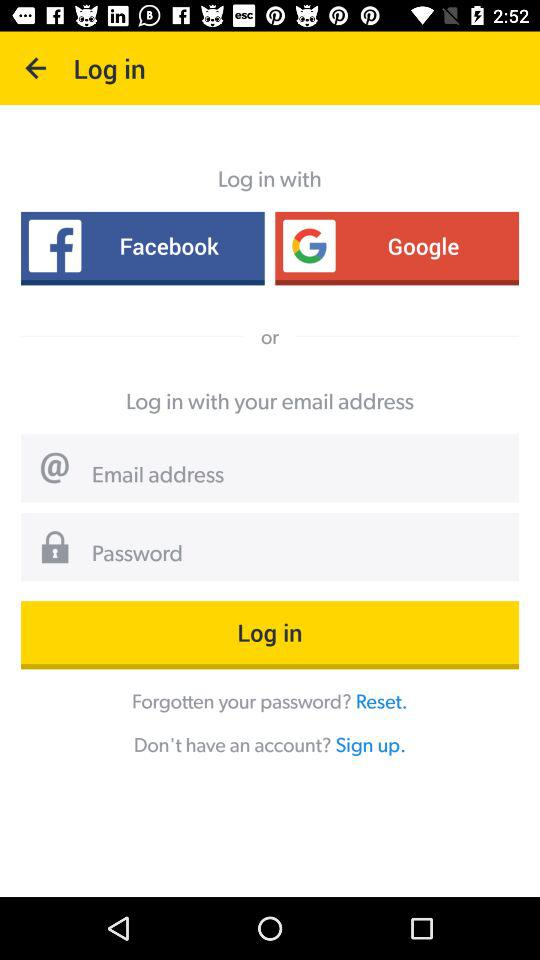How many characters are required to create a password?
When the provided information is insufficient, respond with <no answer>. <no answer> 